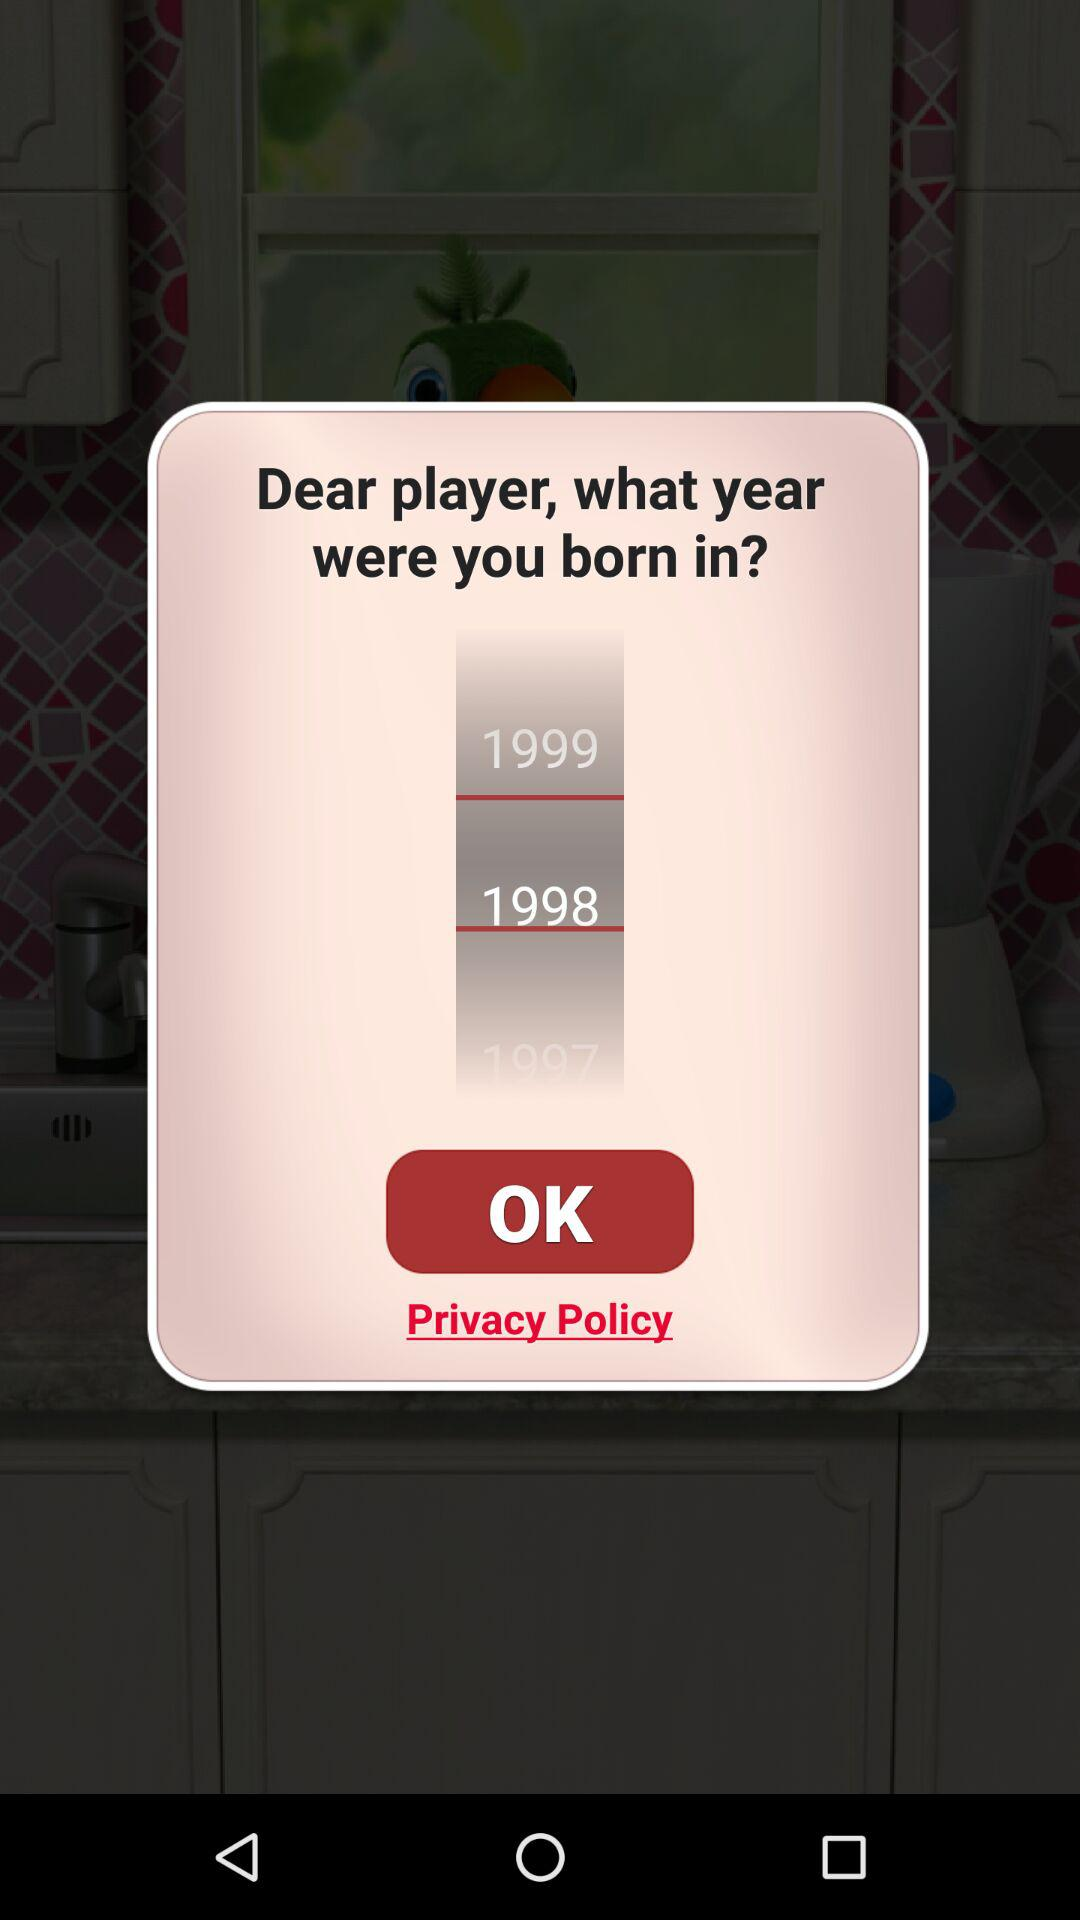How many years are available for the player to choose from?
Answer the question using a single word or phrase. 3 